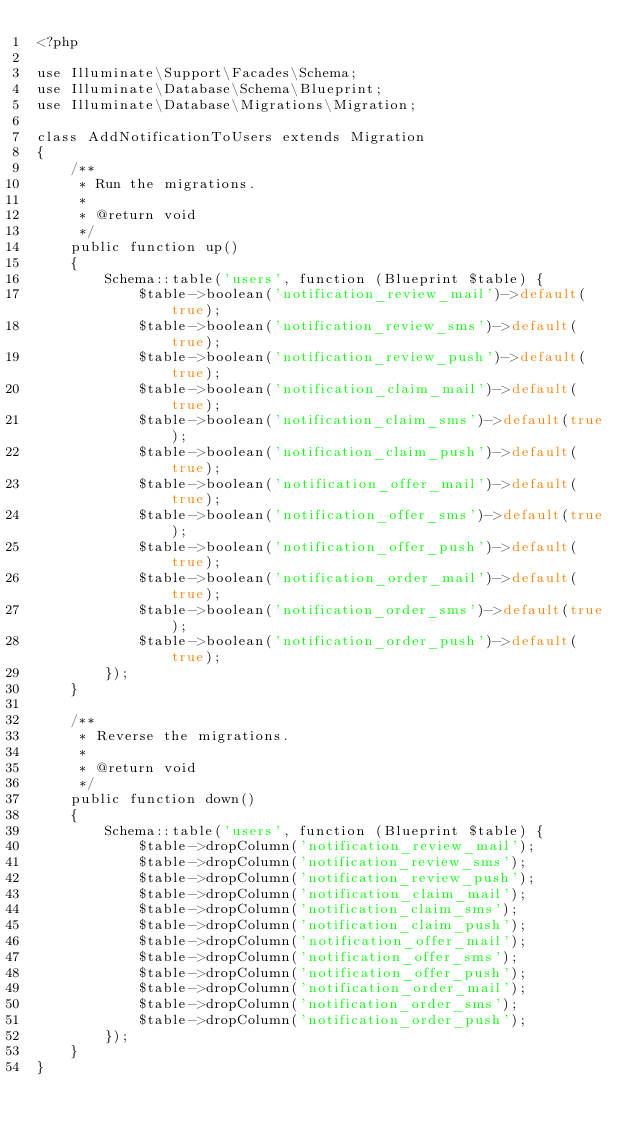<code> <loc_0><loc_0><loc_500><loc_500><_PHP_><?php

use Illuminate\Support\Facades\Schema;
use Illuminate\Database\Schema\Blueprint;
use Illuminate\Database\Migrations\Migration;

class AddNotificationToUsers extends Migration
{
    /**
     * Run the migrations.
     *
     * @return void
     */
    public function up()
    {
        Schema::table('users', function (Blueprint $table) {
            $table->boolean('notification_review_mail')->default(true);
            $table->boolean('notification_review_sms')->default(true);
            $table->boolean('notification_review_push')->default(true);
            $table->boolean('notification_claim_mail')->default(true);
            $table->boolean('notification_claim_sms')->default(true);
            $table->boolean('notification_claim_push')->default(true);
            $table->boolean('notification_offer_mail')->default(true);
            $table->boolean('notification_offer_sms')->default(true);
            $table->boolean('notification_offer_push')->default(true);
            $table->boolean('notification_order_mail')->default(true);
            $table->boolean('notification_order_sms')->default(true);
            $table->boolean('notification_order_push')->default(true);
        });
    }

    /**
     * Reverse the migrations.
     *
     * @return void
     */
    public function down()
    {
        Schema::table('users', function (Blueprint $table) {
            $table->dropColumn('notification_review_mail');
            $table->dropColumn('notification_review_sms');
            $table->dropColumn('notification_review_push');
            $table->dropColumn('notification_claim_mail');
            $table->dropColumn('notification_claim_sms');
            $table->dropColumn('notification_claim_push');
            $table->dropColumn('notification_offer_mail');
            $table->dropColumn('notification_offer_sms');
            $table->dropColumn('notification_offer_push');
            $table->dropColumn('notification_order_mail');
            $table->dropColumn('notification_order_sms');
            $table->dropColumn('notification_order_push');
        });
    }
}
</code> 